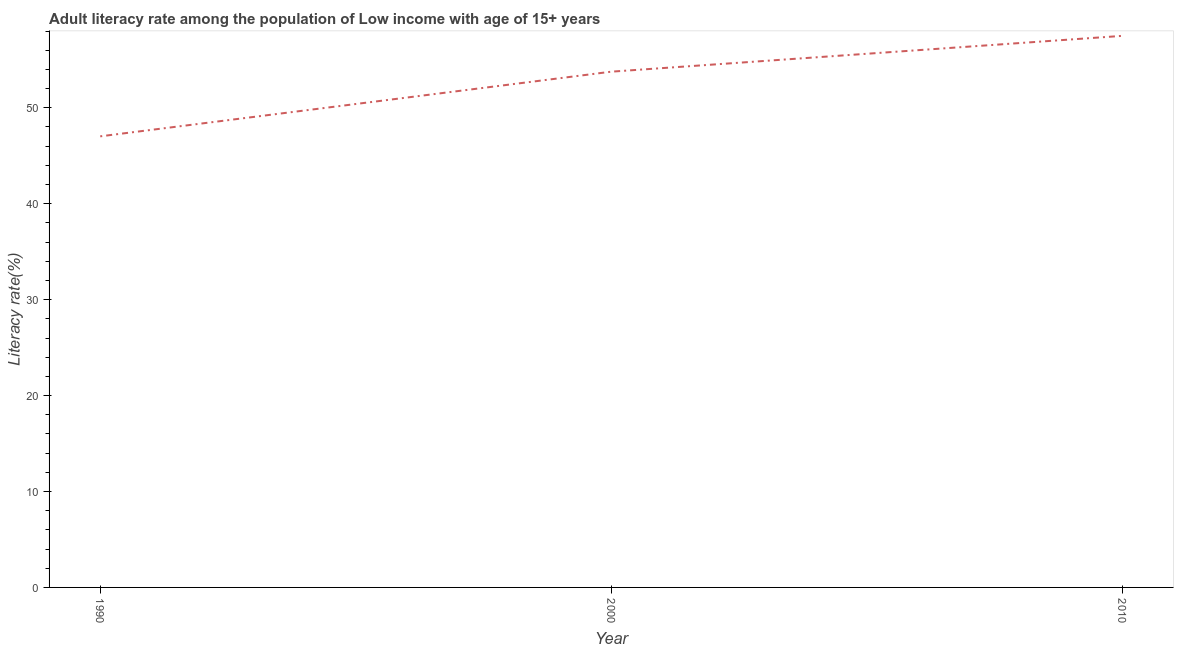What is the adult literacy rate in 1990?
Your answer should be very brief. 47.02. Across all years, what is the maximum adult literacy rate?
Give a very brief answer. 57.5. Across all years, what is the minimum adult literacy rate?
Provide a succinct answer. 47.02. What is the sum of the adult literacy rate?
Your response must be concise. 158.28. What is the difference between the adult literacy rate in 1990 and 2000?
Offer a very short reply. -6.74. What is the average adult literacy rate per year?
Provide a short and direct response. 52.76. What is the median adult literacy rate?
Ensure brevity in your answer.  53.76. In how many years, is the adult literacy rate greater than 32 %?
Your answer should be very brief. 3. Do a majority of the years between 1990 and 2010 (inclusive) have adult literacy rate greater than 40 %?
Offer a terse response. Yes. What is the ratio of the adult literacy rate in 1990 to that in 2000?
Keep it short and to the point. 0.87. Is the difference between the adult literacy rate in 1990 and 2010 greater than the difference between any two years?
Your answer should be compact. Yes. What is the difference between the highest and the second highest adult literacy rate?
Your answer should be compact. 3.73. Is the sum of the adult literacy rate in 1990 and 2010 greater than the maximum adult literacy rate across all years?
Your response must be concise. Yes. What is the difference between the highest and the lowest adult literacy rate?
Provide a short and direct response. 10.47. In how many years, is the adult literacy rate greater than the average adult literacy rate taken over all years?
Offer a very short reply. 2. Does the adult literacy rate monotonically increase over the years?
Keep it short and to the point. Yes. How many lines are there?
Your answer should be compact. 1. Are the values on the major ticks of Y-axis written in scientific E-notation?
Keep it short and to the point. No. Does the graph contain any zero values?
Provide a succinct answer. No. What is the title of the graph?
Your answer should be very brief. Adult literacy rate among the population of Low income with age of 15+ years. What is the label or title of the X-axis?
Offer a terse response. Year. What is the label or title of the Y-axis?
Your answer should be compact. Literacy rate(%). What is the Literacy rate(%) in 1990?
Your response must be concise. 47.02. What is the Literacy rate(%) of 2000?
Ensure brevity in your answer.  53.76. What is the Literacy rate(%) of 2010?
Offer a very short reply. 57.5. What is the difference between the Literacy rate(%) in 1990 and 2000?
Offer a terse response. -6.74. What is the difference between the Literacy rate(%) in 1990 and 2010?
Ensure brevity in your answer.  -10.47. What is the difference between the Literacy rate(%) in 2000 and 2010?
Your response must be concise. -3.73. What is the ratio of the Literacy rate(%) in 1990 to that in 2010?
Ensure brevity in your answer.  0.82. What is the ratio of the Literacy rate(%) in 2000 to that in 2010?
Offer a very short reply. 0.94. 